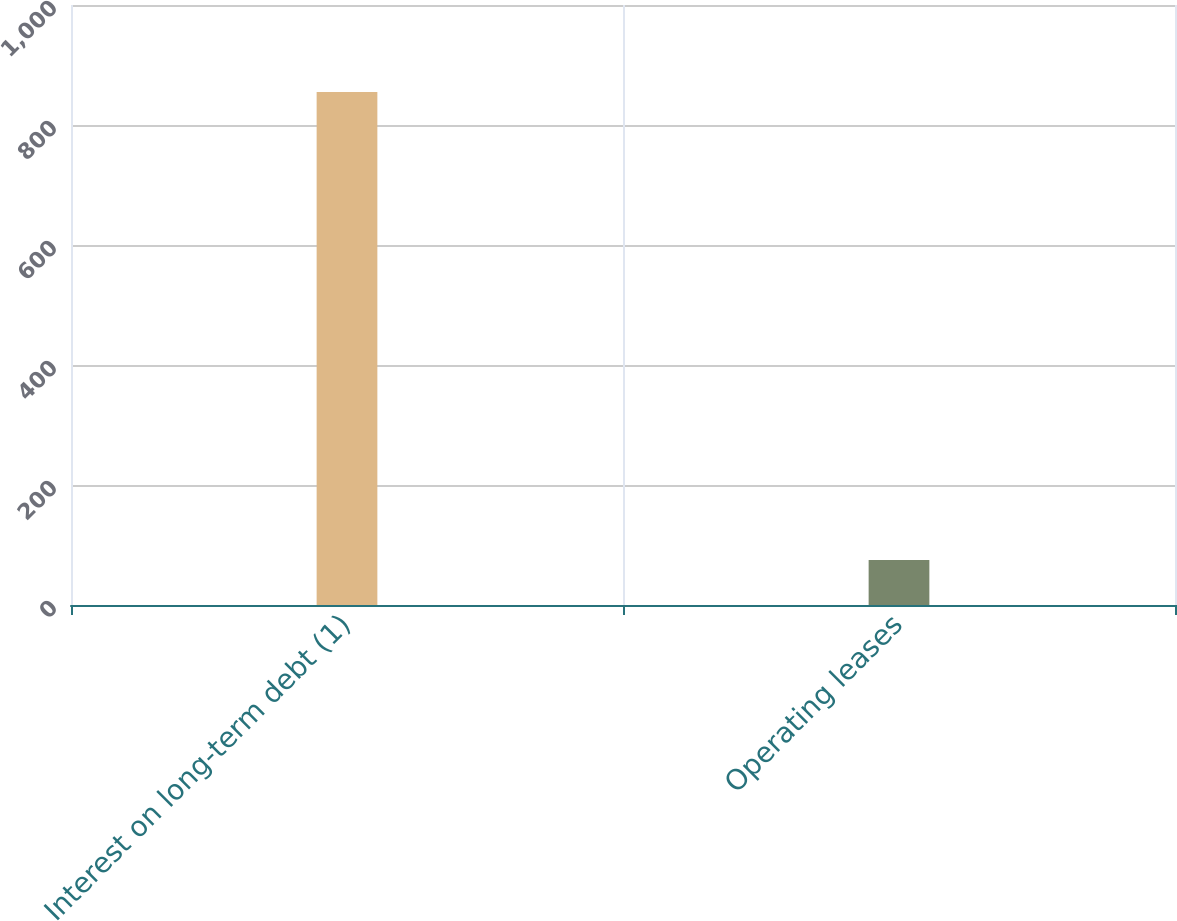<chart> <loc_0><loc_0><loc_500><loc_500><bar_chart><fcel>Interest on long-term debt (1)<fcel>Operating leases<nl><fcel>855<fcel>75<nl></chart> 